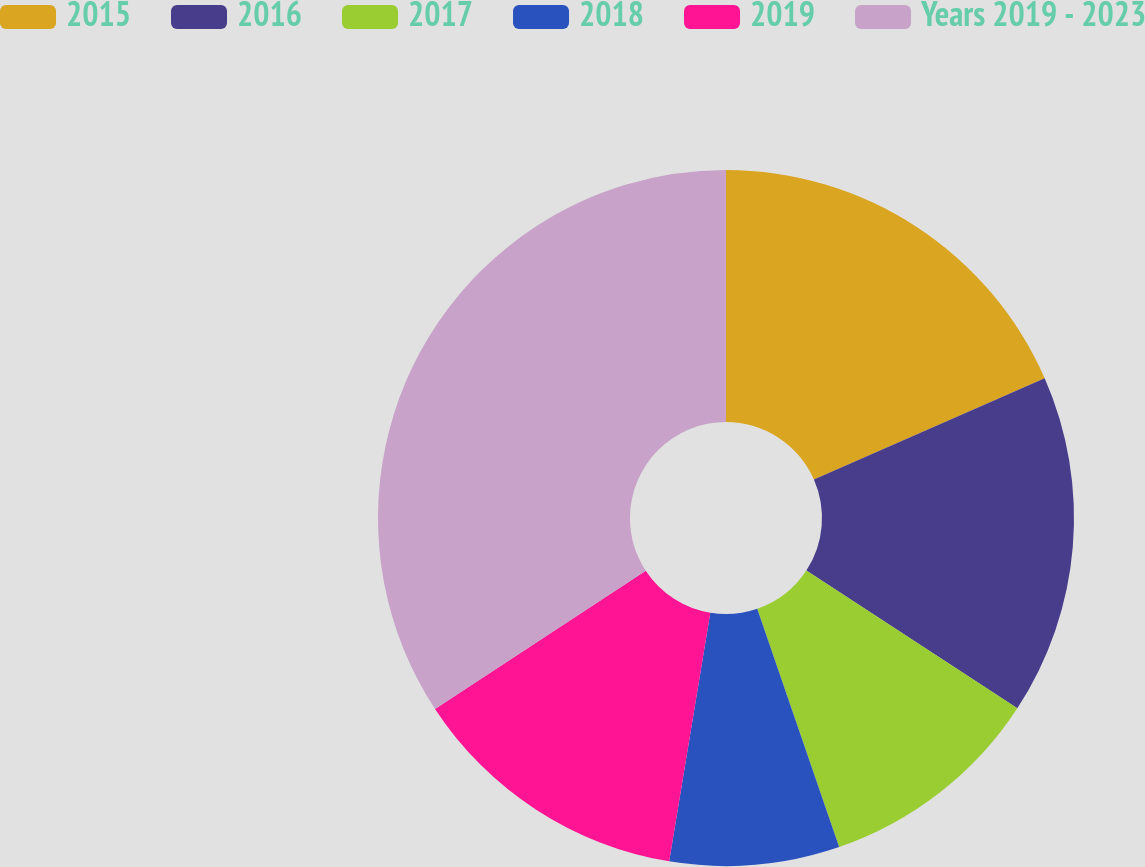<chart> <loc_0><loc_0><loc_500><loc_500><pie_chart><fcel>2015<fcel>2016<fcel>2017<fcel>2018<fcel>2019<fcel>Years 2019 - 2023<nl><fcel>18.42%<fcel>15.79%<fcel>10.52%<fcel>7.88%<fcel>13.15%<fcel>34.24%<nl></chart> 